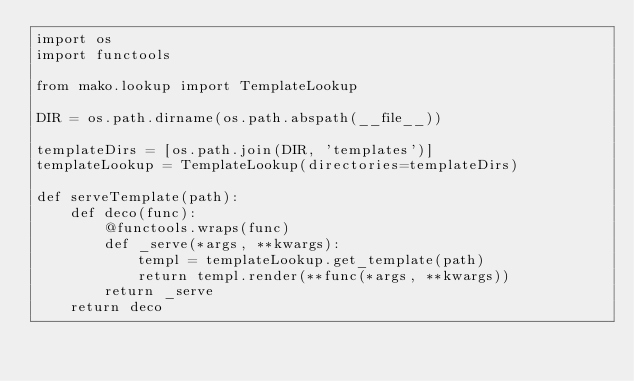Convert code to text. <code><loc_0><loc_0><loc_500><loc_500><_Python_>import os
import functools

from mako.lookup import TemplateLookup

DIR = os.path.dirname(os.path.abspath(__file__))

templateDirs = [os.path.join(DIR, 'templates')]
templateLookup = TemplateLookup(directories=templateDirs)

def serveTemplate(path):
    def deco(func):
        @functools.wraps(func)
        def _serve(*args, **kwargs):
            templ = templateLookup.get_template(path)
            return templ.render(**func(*args, **kwargs))
        return _serve
    return deco
</code> 